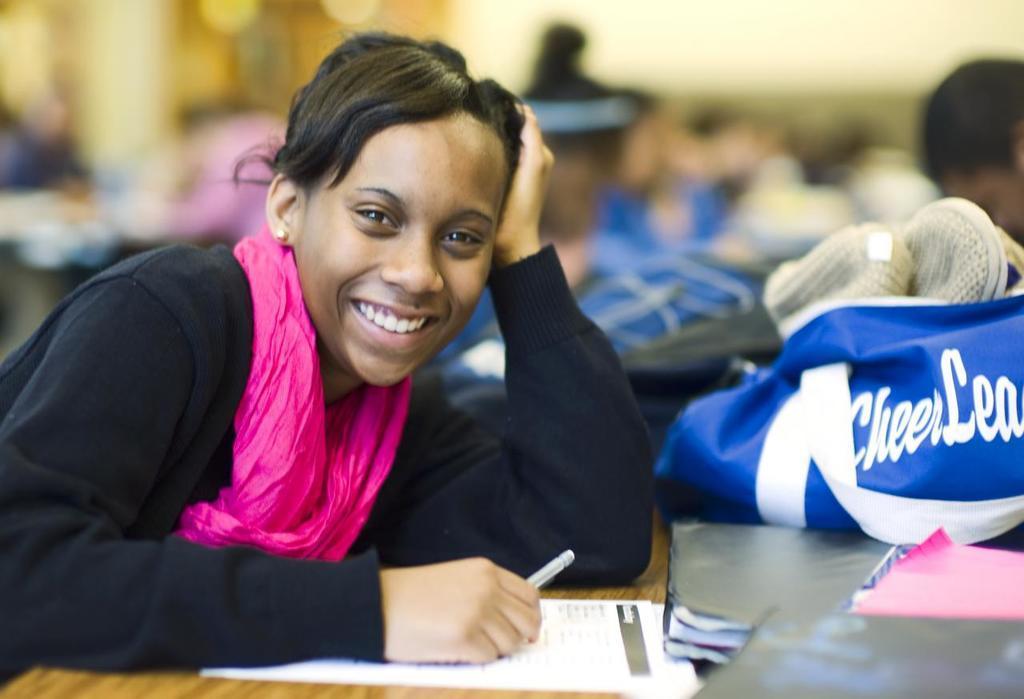How would you summarize this image in a sentence or two? In the foreground of this picture, there is a girl in black T shirt leaning on a table having smile on her face. She is holding a pencil in her hand. In the background, there is a bag and persons near a table. 